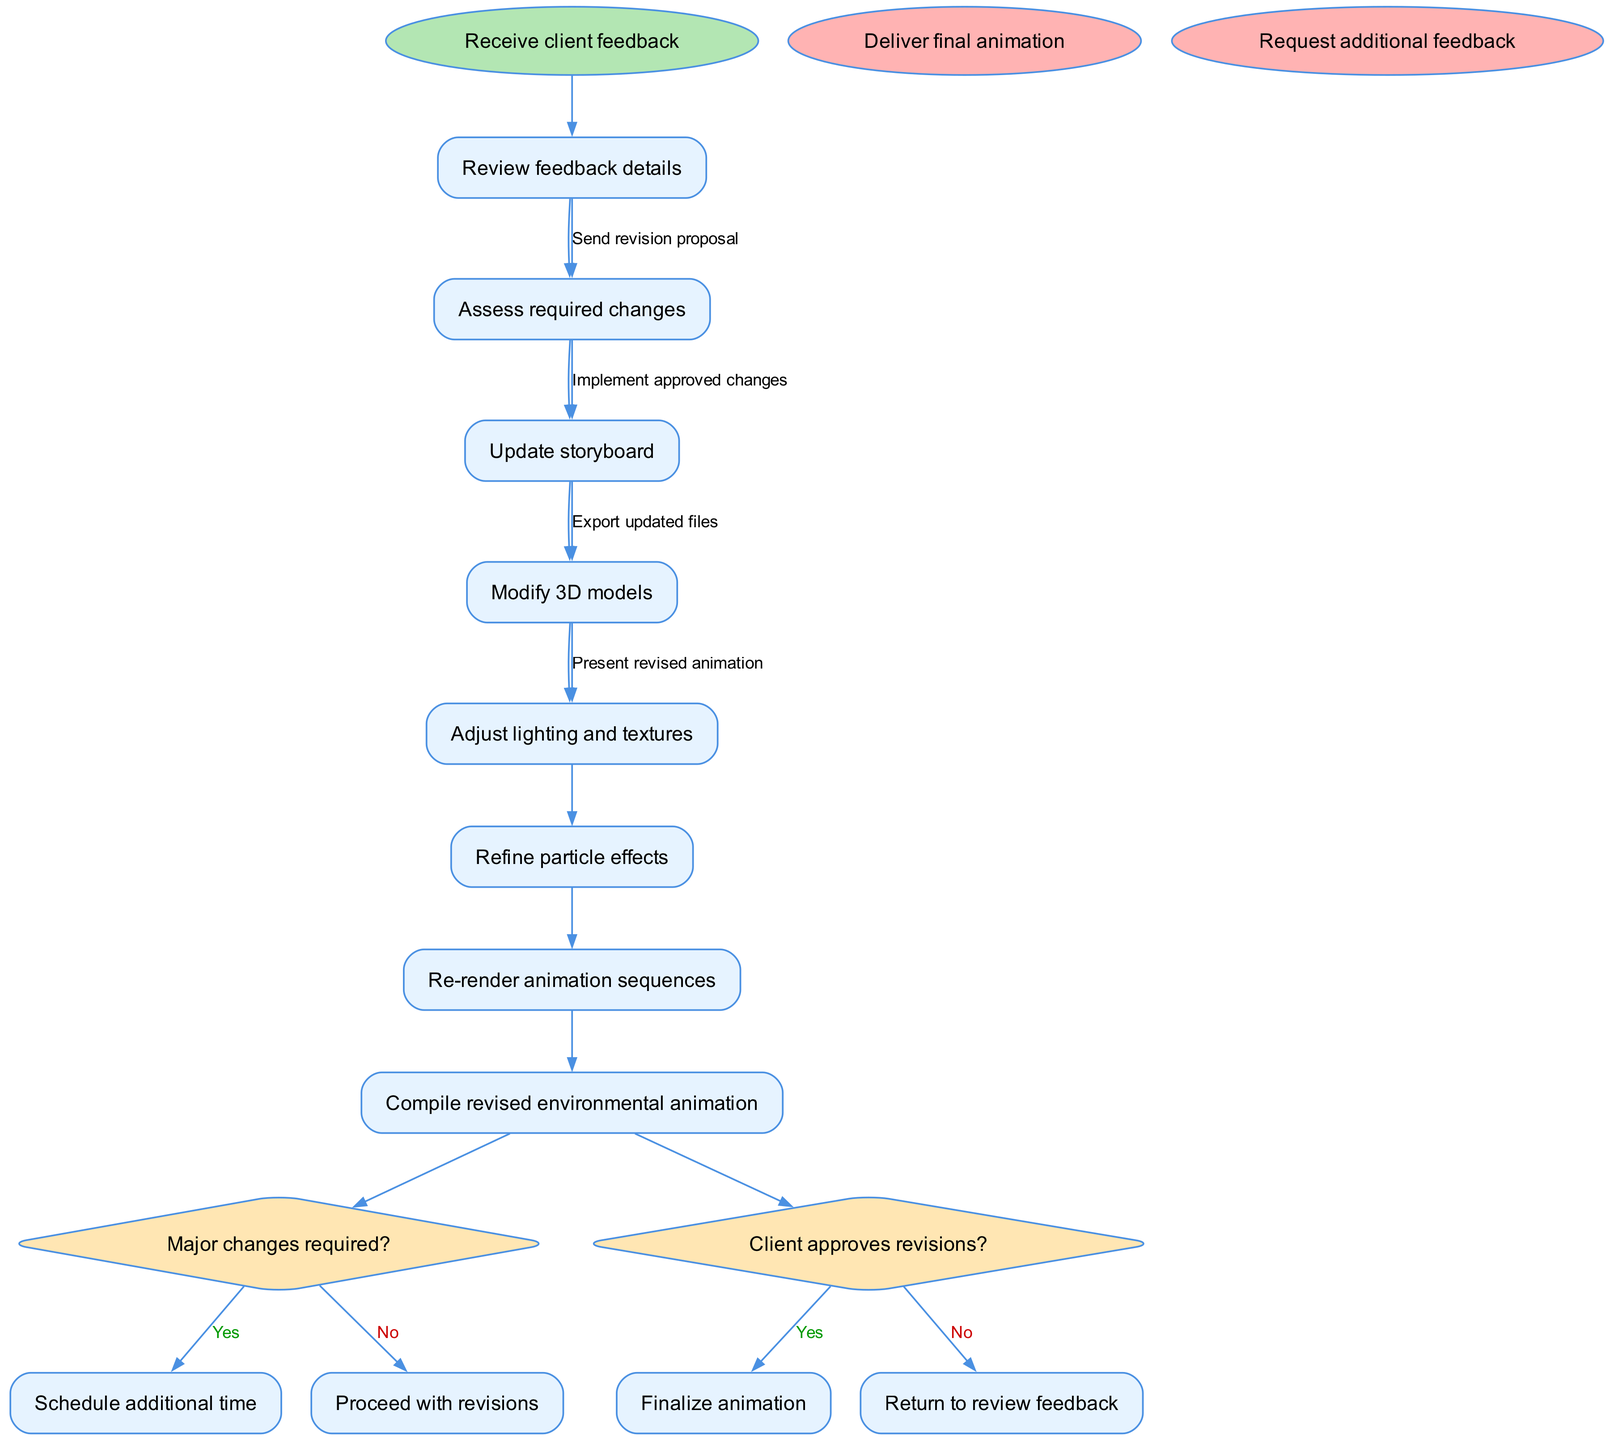What is the first activity after receiving client feedback? The first activity in the diagram, after the "Receive client feedback" node, is "Review feedback details." This is directly indicated in the flow of activities that follows the starting node.
Answer: Review feedback details How many activities are listed in the diagram? The diagram lists a total of 8 activities, which are outlined sequentially after the start node. This is obtained by counting each activity shown in the activities array.
Answer: 8 What is the decision point that follows the last activity? The decision point that follows the last activity, "Re-render animation sequences," is labeled "Client approves revisions?" This is a decision node that branches based on client approval.
Answer: Client approves revisions? If the answer to "Major changes required?" is No, what is the next step? If the answer to the decision "Major changes required?" is No, the process proceeds to "Proceed with revisions," which connects directly to the next activities of updating the storyboard and modifying 3D models.
Answer: Proceed with revisions What happens after the "Client approves revisions?" decision point if the answer is No? If the answer to "Client approves revisions?" is No, the process returns to the "Review feedback details" node, indicating a loop back to reconsider client feedback before implementing changes again.
Answer: Return to review feedback Which activity directly leads to the "Deliver final animation" end node? The activity "Finalize animation" directly leads to the "Deliver final animation" end node as part of the end game of the approval process, indicating completion.
Answer: Finalize animation What is the shape of decision nodes in this diagram? The decision nodes in this activity diagram are represented as diamonds, which is a standard shape used to indicate decision points where multiple paths can diverge based on a Yes/No response.
Answer: Diamond How many end nodes are provided in the diagram? There are 2 end nodes in the diagram: "Deliver final animation" and "Request additional feedback." These indicate possible endpoints for the animation process based on client interactions.
Answer: 2 